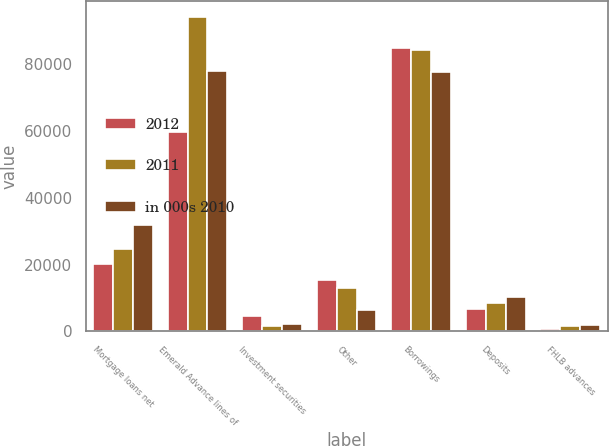<chart> <loc_0><loc_0><loc_500><loc_500><stacked_bar_chart><ecel><fcel>Mortgage loans net<fcel>Emerald Advance lines of<fcel>Investment securities<fcel>Other<fcel>Borrowings<fcel>Deposits<fcel>FHLB advances<nl><fcel>2012<fcel>20322<fcel>59660<fcel>4463<fcel>15355<fcel>84782<fcel>6735<fcel>572<nl><fcel>2011<fcel>24693<fcel>94300<fcel>1609<fcel>13058<fcel>84169<fcel>8488<fcel>1526<nl><fcel>in 000s 2010<fcel>31877<fcel>77891<fcel>2318<fcel>6274<fcel>77659<fcel>10174<fcel>1997<nl></chart> 